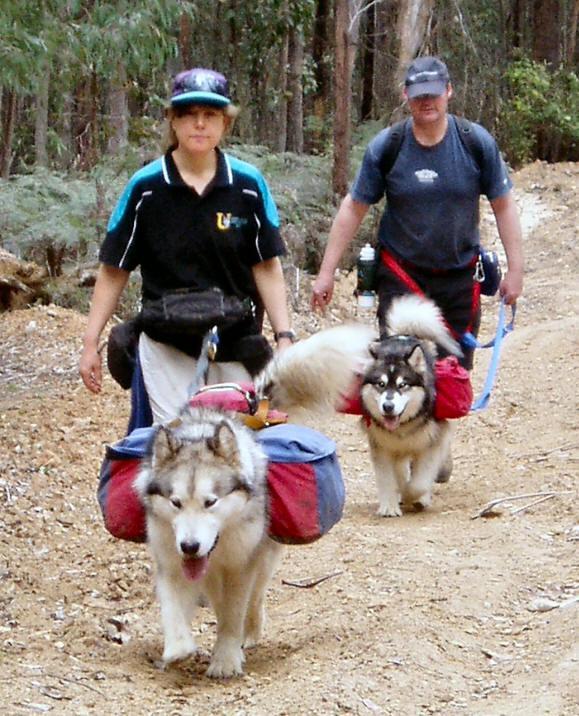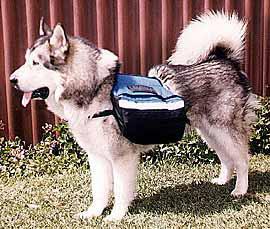The first image is the image on the left, the second image is the image on the right. Assess this claim about the two images: "At least one of the dogs does not have a backpack on its back.". Correct or not? Answer yes or no. No. The first image is the image on the left, the second image is the image on the right. Analyze the images presented: Is the assertion "In the left image, two furry dogs are seen wearing packs on their backs." valid? Answer yes or no. Yes. 